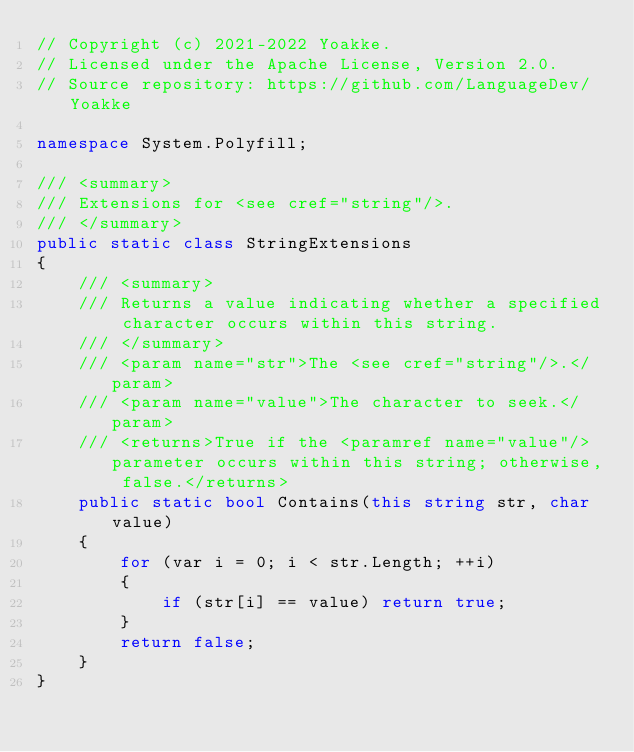<code> <loc_0><loc_0><loc_500><loc_500><_C#_>// Copyright (c) 2021-2022 Yoakke.
// Licensed under the Apache License, Version 2.0.
// Source repository: https://github.com/LanguageDev/Yoakke

namespace System.Polyfill;

/// <summary>
/// Extensions for <see cref="string"/>.
/// </summary>
public static class StringExtensions
{
    /// <summary>
    /// Returns a value indicating whether a specified character occurs within this string.
    /// </summary>
    /// <param name="str">The <see cref="string"/>.</param>
    /// <param name="value">The character to seek.</param>
    /// <returns>True if the <paramref name="value"/> parameter occurs within this string; otherwise, false.</returns>
    public static bool Contains(this string str, char value)
    {
        for (var i = 0; i < str.Length; ++i)
        {
            if (str[i] == value) return true;
        }
        return false;
    }
}
</code> 